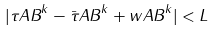Convert formula to latex. <formula><loc_0><loc_0><loc_500><loc_500>| \tau _ { \tt } { A B } ^ { k } - \bar { \tau } _ { \tt } { A B } ^ { k } + w _ { \tt } { A B } ^ { k } | < L</formula> 